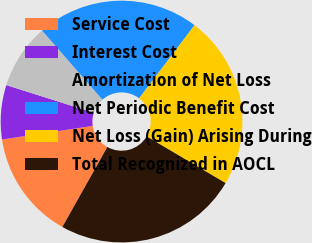Convert chart. <chart><loc_0><loc_0><loc_500><loc_500><pie_chart><fcel>Service Cost<fcel>Interest Cost<fcel>Amortization of Net Loss<fcel>Net Periodic Benefit Cost<fcel>Net Loss (Gain) Arising During<fcel>Total Recognized in AOCL<nl><fcel>14.49%<fcel>7.25%<fcel>8.7%<fcel>21.74%<fcel>23.19%<fcel>24.64%<nl></chart> 